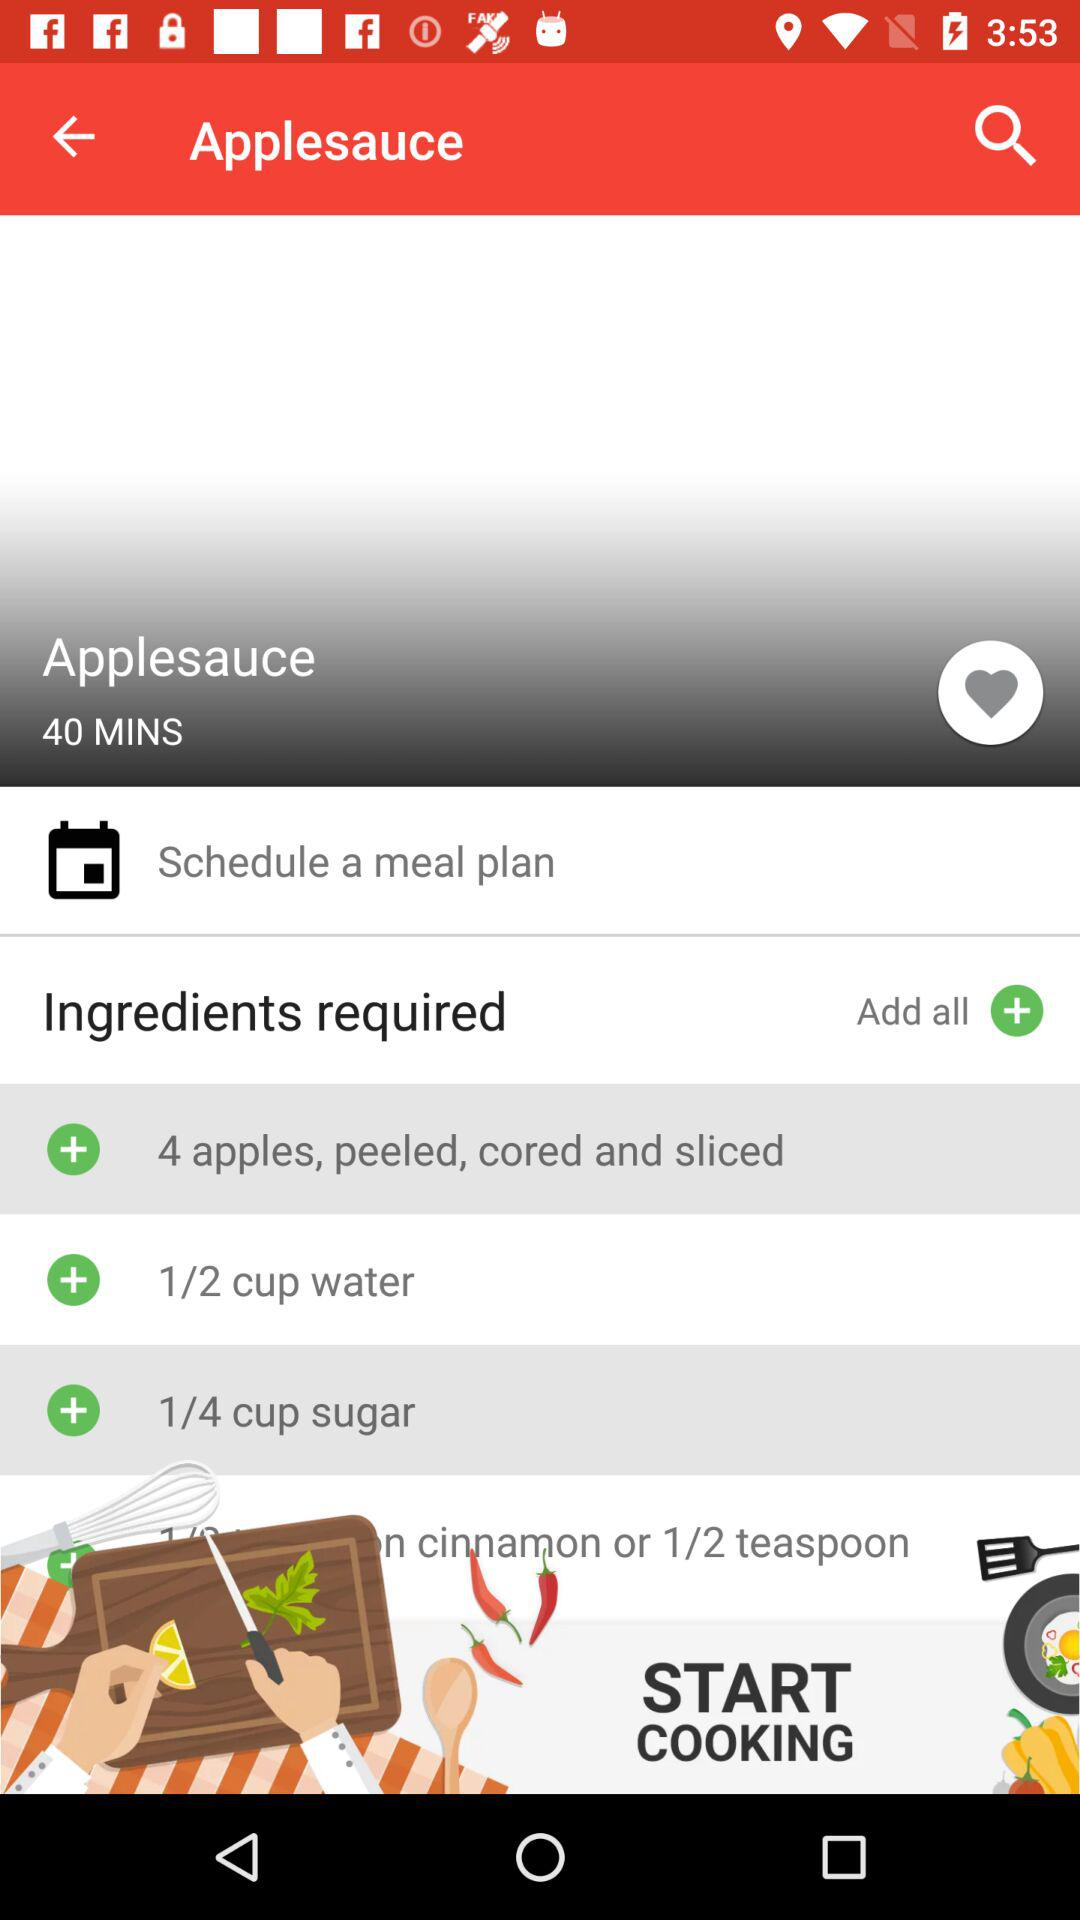How many apples did we need to make "Applesauce"? You needed 4 apples. 